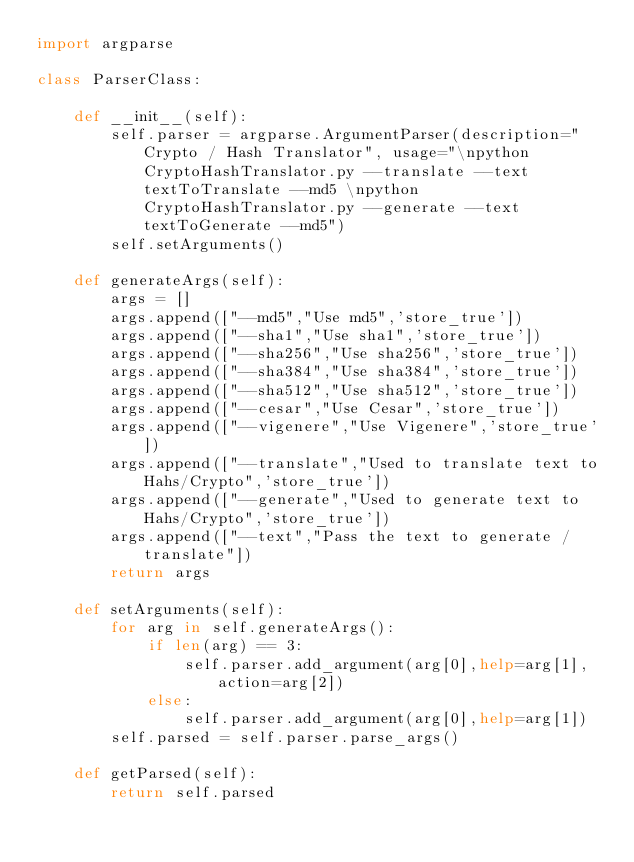<code> <loc_0><loc_0><loc_500><loc_500><_Python_>import argparse

class ParserClass:

    def __init__(self):
        self.parser = argparse.ArgumentParser(description="Crypto / Hash Translator", usage="\npython CryptoHashTranslator.py --translate --text textToTranslate --md5 \npython CryptoHashTranslator.py --generate --text textToGenerate --md5")
        self.setArguments()
    
    def generateArgs(self):
        args = []
        args.append(["--md5","Use md5",'store_true'])
        args.append(["--sha1","Use sha1",'store_true'])
        args.append(["--sha256","Use sha256",'store_true'])
        args.append(["--sha384","Use sha384",'store_true'])
        args.append(["--sha512","Use sha512",'store_true'])
        args.append(["--cesar","Use Cesar",'store_true'])
        args.append(["--vigenere","Use Vigenere",'store_true'])
        args.append(["--translate","Used to translate text to Hahs/Crypto",'store_true'])
        args.append(["--generate","Used to generate text to Hahs/Crypto",'store_true'])
        args.append(["--text","Pass the text to generate / translate"])
        return args

    def setArguments(self):
        for arg in self.generateArgs():
            if len(arg) == 3:
                self.parser.add_argument(arg[0],help=arg[1],action=arg[2])
            else:
                self.parser.add_argument(arg[0],help=arg[1])
        self.parsed = self.parser.parse_args()

    def getParsed(self):
        return self.parsed
</code> 